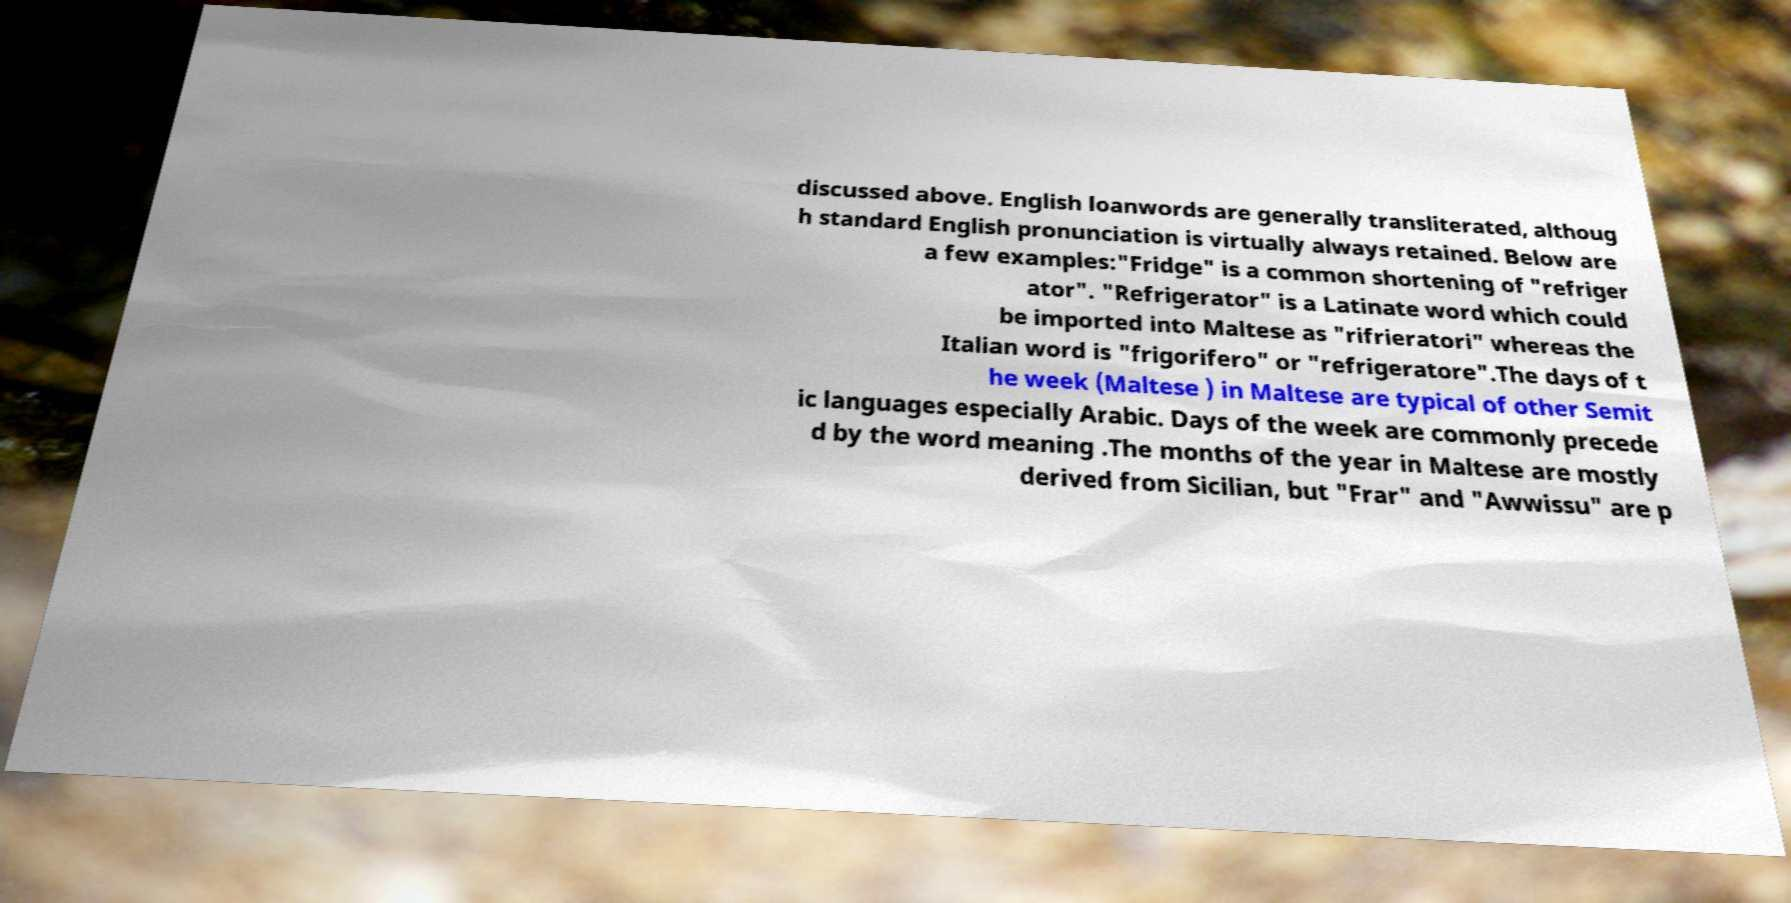Please read and relay the text visible in this image. What does it say? discussed above. English loanwords are generally transliterated, althoug h standard English pronunciation is virtually always retained. Below are a few examples:"Fridge" is a common shortening of "refriger ator". "Refrigerator" is a Latinate word which could be imported into Maltese as "rifrieratori" whereas the Italian word is "frigorifero" or "refrigeratore".The days of t he week (Maltese ) in Maltese are typical of other Semit ic languages especially Arabic. Days of the week are commonly precede d by the word meaning .The months of the year in Maltese are mostly derived from Sicilian, but "Frar" and "Awwissu" are p 